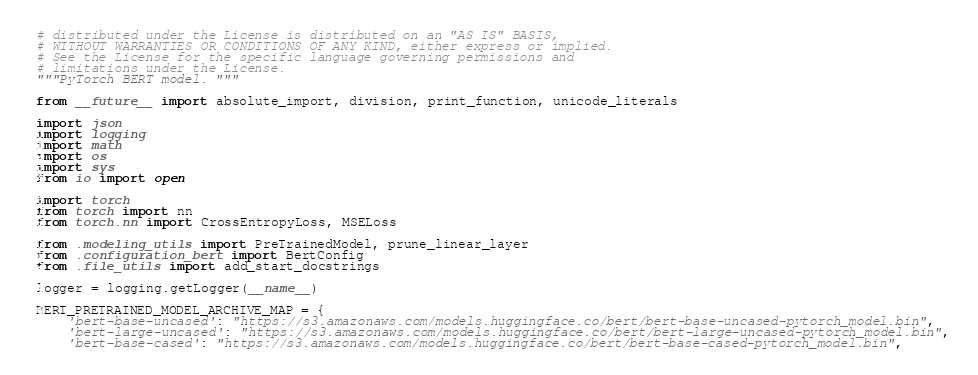Convert code to text. <code><loc_0><loc_0><loc_500><loc_500><_Python_># distributed under the License is distributed on an "AS IS" BASIS,
# WITHOUT WARRANTIES OR CONDITIONS OF ANY KIND, either express or implied.
# See the License for the specific language governing permissions and
# limitations under the License.
"""PyTorch BERT model. """

from __future__ import absolute_import, division, print_function, unicode_literals

import json
import logging
import math
import os
import sys
from io import open

import torch
from torch import nn
from torch.nn import CrossEntropyLoss, MSELoss

from .modeling_utils import PreTrainedModel, prune_linear_layer
from .configuration_bert import BertConfig
from .file_utils import add_start_docstrings

logger = logging.getLogger(__name__)

BERT_PRETRAINED_MODEL_ARCHIVE_MAP = {
    'bert-base-uncased': "https://s3.amazonaws.com/models.huggingface.co/bert/bert-base-uncased-pytorch_model.bin",
    'bert-large-uncased': "https://s3.amazonaws.com/models.huggingface.co/bert/bert-large-uncased-pytorch_model.bin",
    'bert-base-cased': "https://s3.amazonaws.com/models.huggingface.co/bert/bert-base-cased-pytorch_model.bin",</code> 